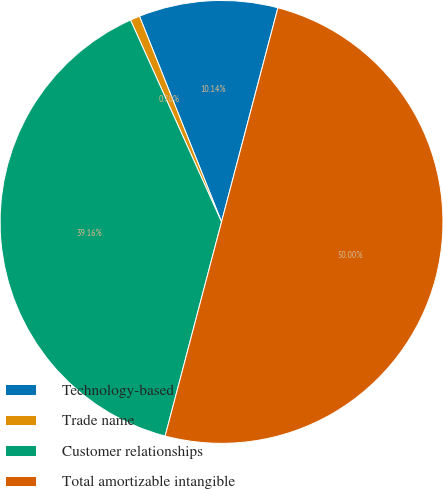Convert chart to OTSL. <chart><loc_0><loc_0><loc_500><loc_500><pie_chart><fcel>Technology-based<fcel>Trade name<fcel>Customer relationships<fcel>Total amortizable intangible<nl><fcel>10.14%<fcel>0.7%<fcel>39.16%<fcel>50.0%<nl></chart> 